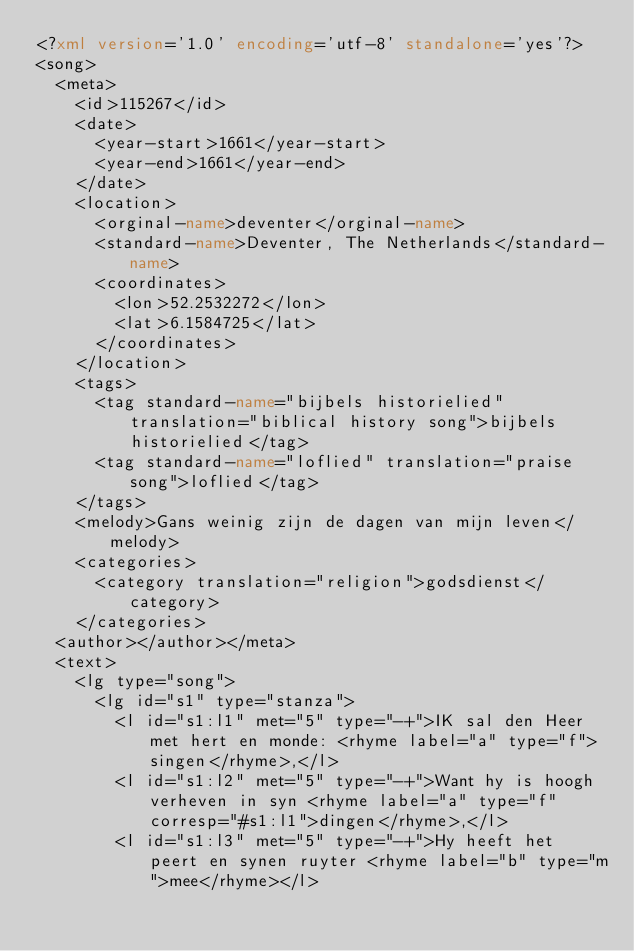<code> <loc_0><loc_0><loc_500><loc_500><_XML_><?xml version='1.0' encoding='utf-8' standalone='yes'?>
<song>
  <meta>
    <id>115267</id>
    <date>
      <year-start>1661</year-start>
      <year-end>1661</year-end>
    </date>
    <location>
      <orginal-name>deventer</orginal-name>
      <standard-name>Deventer, The Netherlands</standard-name>
      <coordinates>
        <lon>52.2532272</lon>
        <lat>6.1584725</lat>
      </coordinates>
    </location>
    <tags>
      <tag standard-name="bijbels historielied" translation="biblical history song">bijbels historielied</tag>
      <tag standard-name="loflied" translation="praise song">loflied</tag>
    </tags>
    <melody>Gans weinig zijn de dagen van mijn leven</melody>
    <categories>
      <category translation="religion">godsdienst</category>
    </categories>
  <author></author></meta>
  <text>
    <lg type="song">
      <lg id="s1" type="stanza">
        <l id="s1:l1" met="5" type="-+">IK sal den Heer met hert en monde: <rhyme label="a" type="f">singen</rhyme>,</l>
        <l id="s1:l2" met="5" type="-+">Want hy is hoogh verheven in syn <rhyme label="a" type="f" corresp="#s1:l1">dingen</rhyme>,</l>
        <l id="s1:l3" met="5" type="-+">Hy heeft het peert en synen ruyter <rhyme label="b" type="m">mee</rhyme></l></code> 